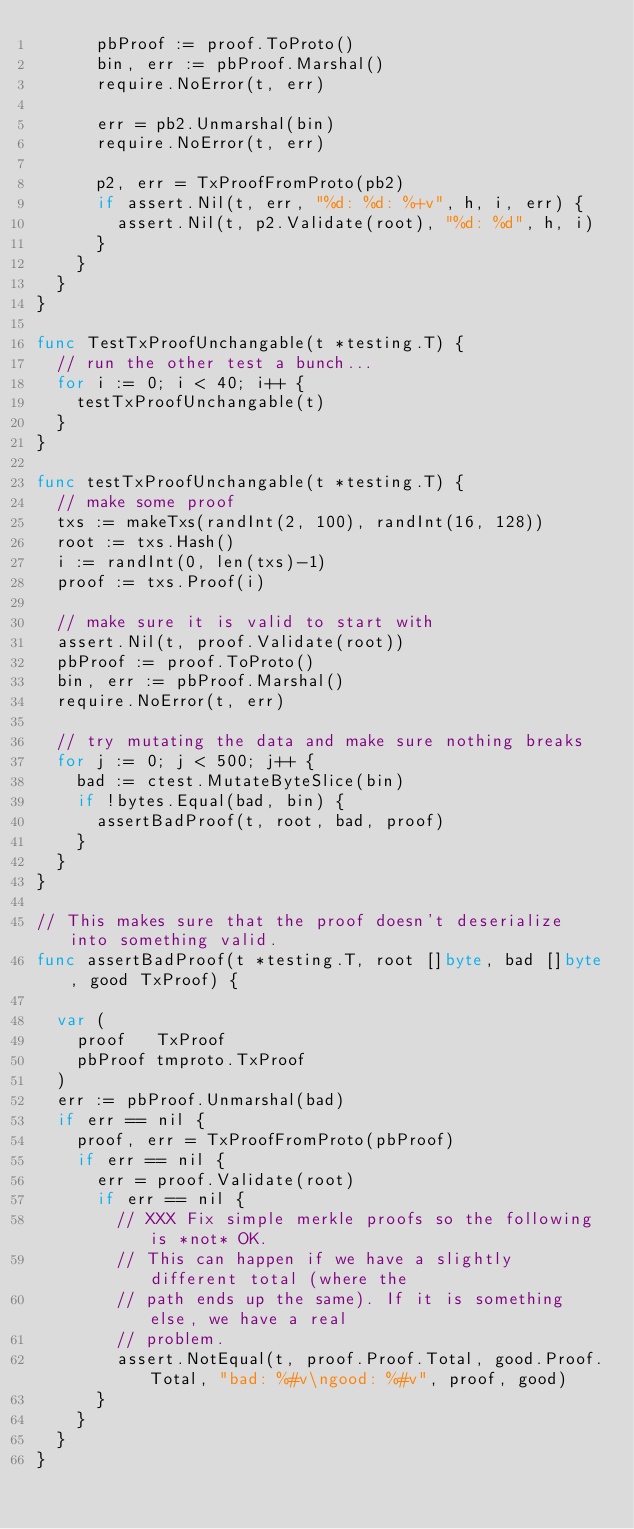Convert code to text. <code><loc_0><loc_0><loc_500><loc_500><_Go_>			pbProof := proof.ToProto()
			bin, err := pbProof.Marshal()
			require.NoError(t, err)

			err = pb2.Unmarshal(bin)
			require.NoError(t, err)

			p2, err = TxProofFromProto(pb2)
			if assert.Nil(t, err, "%d: %d: %+v", h, i, err) {
				assert.Nil(t, p2.Validate(root), "%d: %d", h, i)
			}
		}
	}
}

func TestTxProofUnchangable(t *testing.T) {
	// run the other test a bunch...
	for i := 0; i < 40; i++ {
		testTxProofUnchangable(t)
	}
}

func testTxProofUnchangable(t *testing.T) {
	// make some proof
	txs := makeTxs(randInt(2, 100), randInt(16, 128))
	root := txs.Hash()
	i := randInt(0, len(txs)-1)
	proof := txs.Proof(i)

	// make sure it is valid to start with
	assert.Nil(t, proof.Validate(root))
	pbProof := proof.ToProto()
	bin, err := pbProof.Marshal()
	require.NoError(t, err)

	// try mutating the data and make sure nothing breaks
	for j := 0; j < 500; j++ {
		bad := ctest.MutateByteSlice(bin)
		if !bytes.Equal(bad, bin) {
			assertBadProof(t, root, bad, proof)
		}
	}
}

// This makes sure that the proof doesn't deserialize into something valid.
func assertBadProof(t *testing.T, root []byte, bad []byte, good TxProof) {

	var (
		proof   TxProof
		pbProof tmproto.TxProof
	)
	err := pbProof.Unmarshal(bad)
	if err == nil {
		proof, err = TxProofFromProto(pbProof)
		if err == nil {
			err = proof.Validate(root)
			if err == nil {
				// XXX Fix simple merkle proofs so the following is *not* OK.
				// This can happen if we have a slightly different total (where the
				// path ends up the same). If it is something else, we have a real
				// problem.
				assert.NotEqual(t, proof.Proof.Total, good.Proof.Total, "bad: %#v\ngood: %#v", proof, good)
			}
		}
	}
}
</code> 